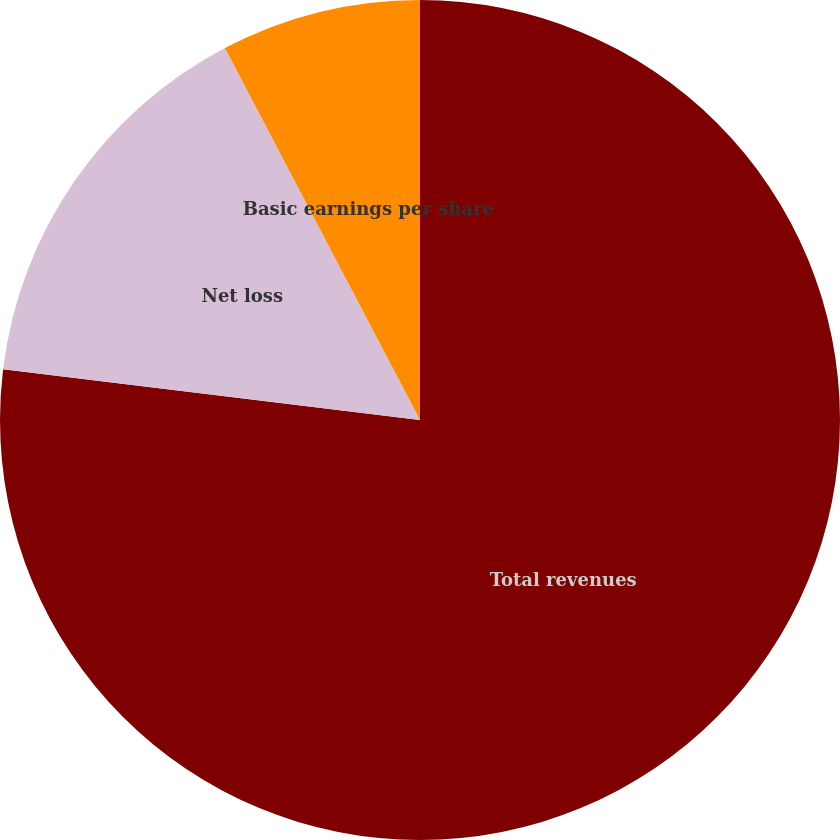Convert chart to OTSL. <chart><loc_0><loc_0><loc_500><loc_500><pie_chart><fcel>Total revenues<fcel>Net loss<fcel>Basic earnings per share<fcel>Diluted earnings per share<nl><fcel>76.92%<fcel>15.38%<fcel>7.69%<fcel>0.0%<nl></chart> 